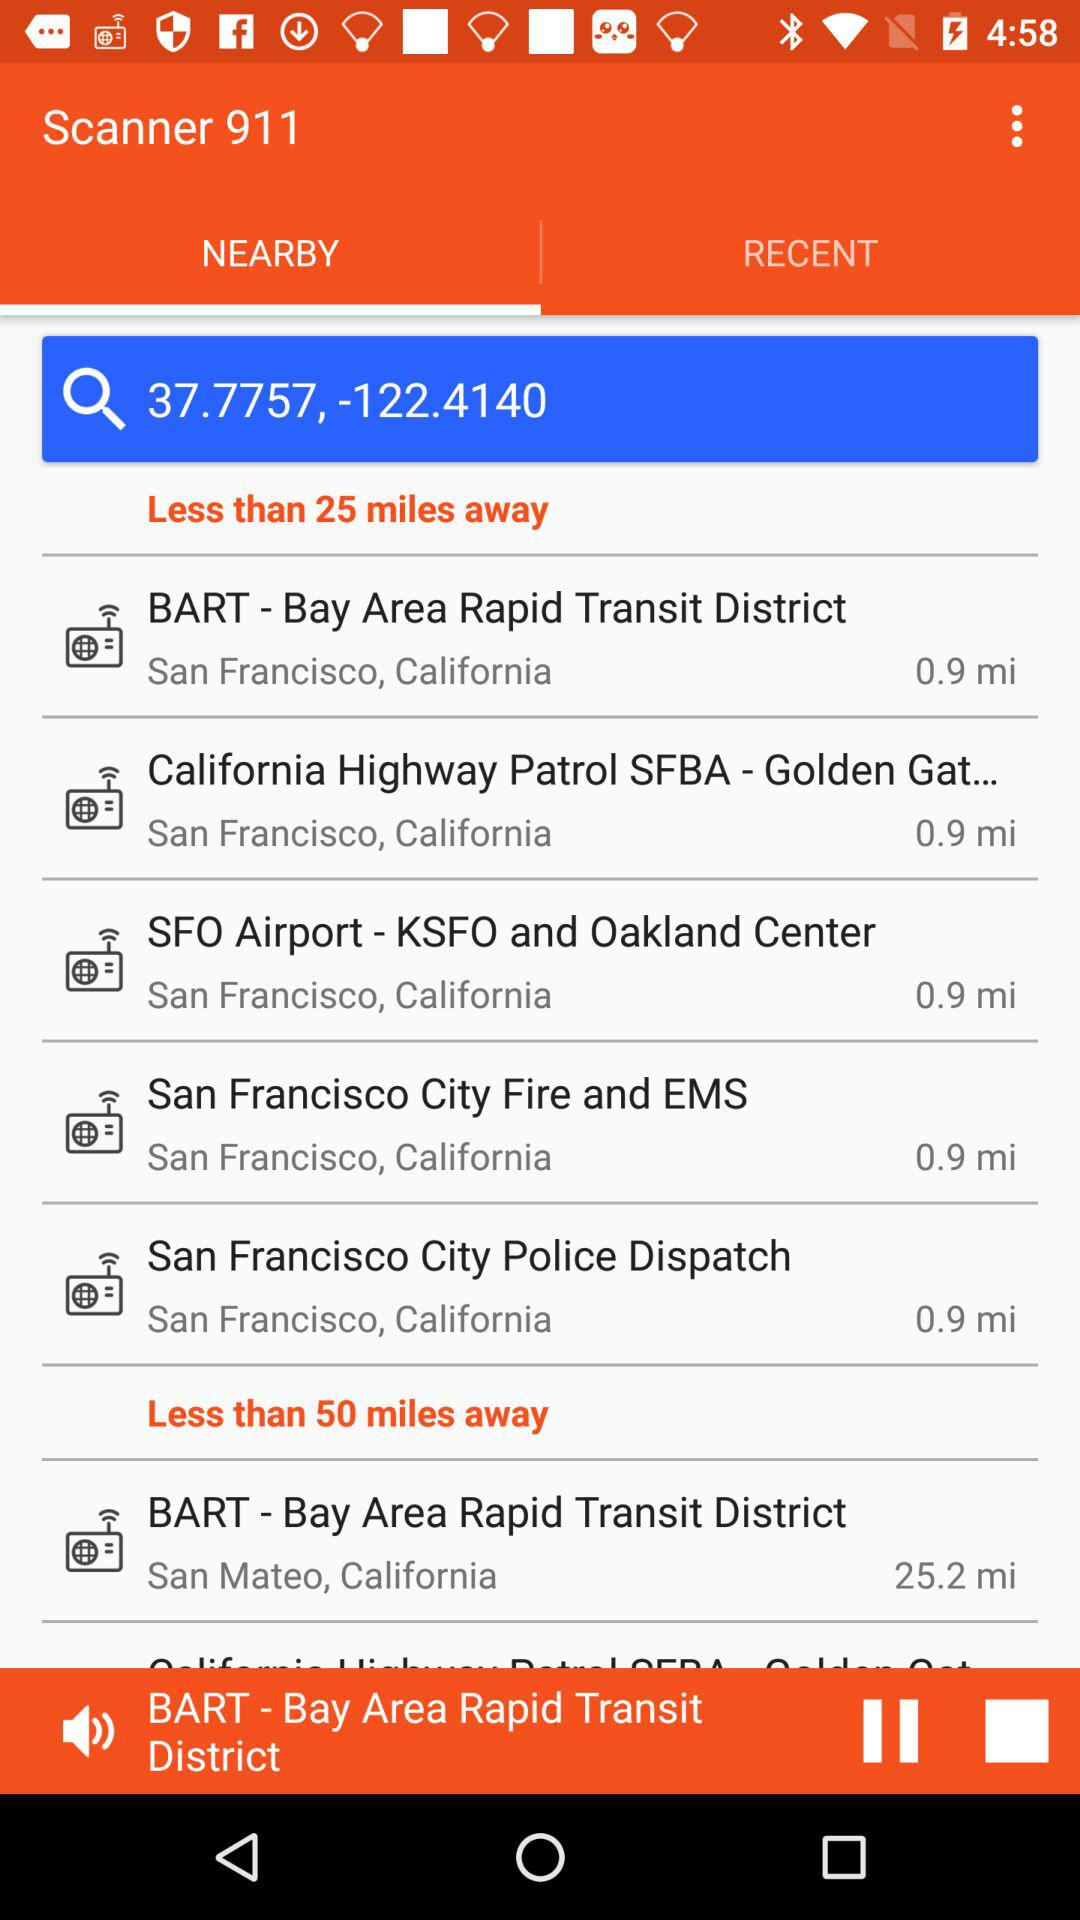How many miles away is BART San Francisco? BART San Francisco is 0.9 miles away. 